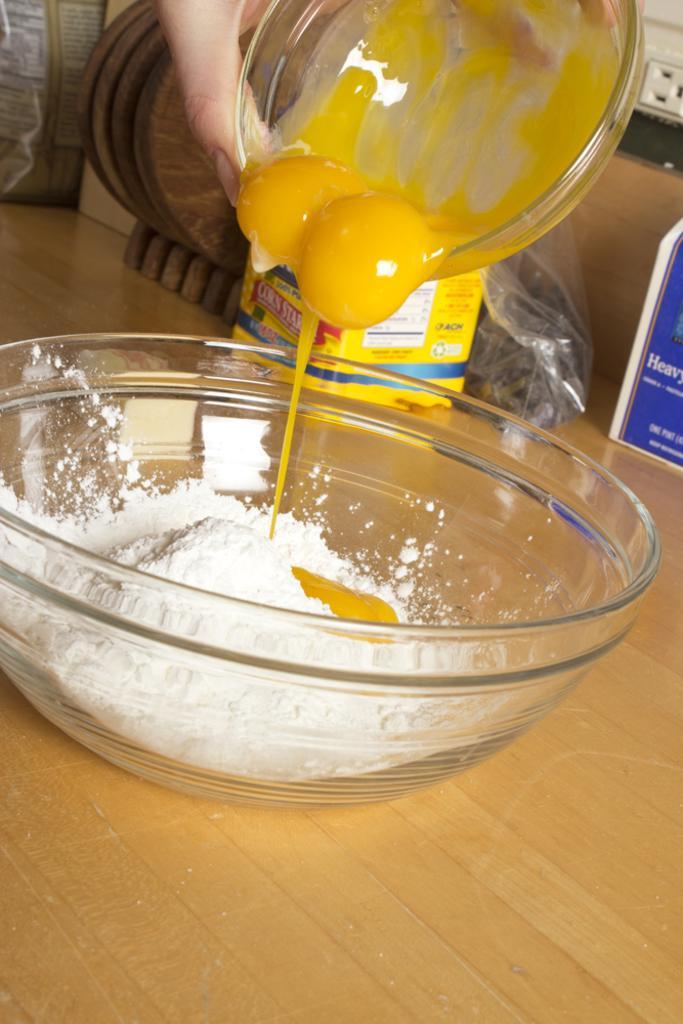How would you summarize this image in a sentence or two? In the picture I can see a bowl which has a white powder in it and there is egg yolk in the bowl above it and there are few other objects in the background. 